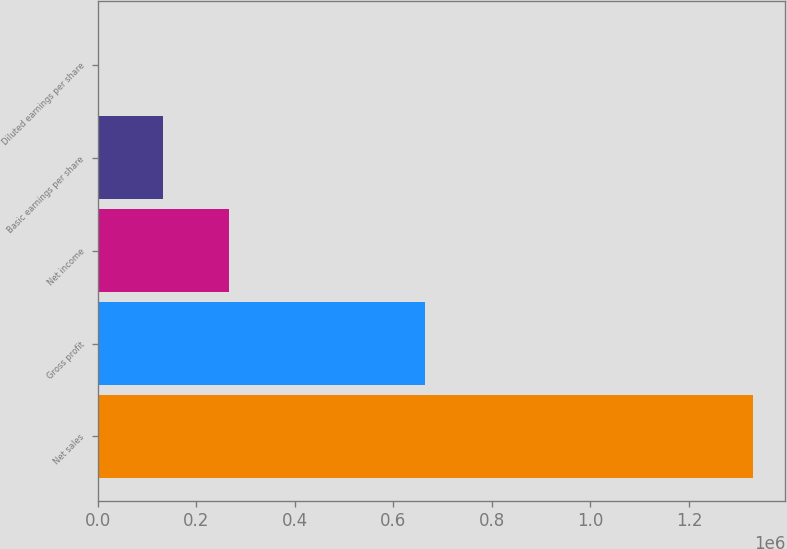Convert chart to OTSL. <chart><loc_0><loc_0><loc_500><loc_500><bar_chart><fcel>Net sales<fcel>Gross profit<fcel>Net income<fcel>Basic earnings per share<fcel>Diluted earnings per share<nl><fcel>1.3292e+06<fcel>663155<fcel>265841<fcel>132921<fcel>0.88<nl></chart> 